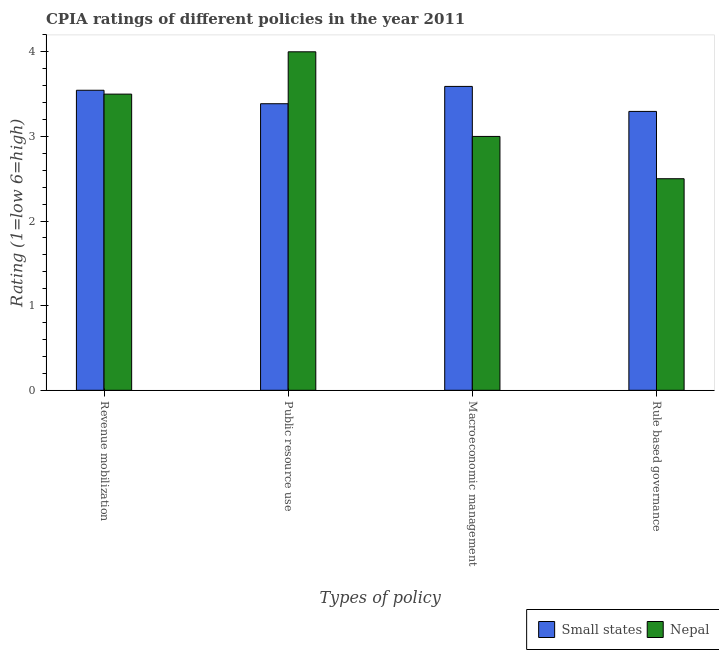How many different coloured bars are there?
Your answer should be compact. 2. How many bars are there on the 4th tick from the left?
Offer a very short reply. 2. How many bars are there on the 1st tick from the right?
Your response must be concise. 2. What is the label of the 1st group of bars from the left?
Ensure brevity in your answer.  Revenue mobilization. Across all countries, what is the maximum cpia rating of public resource use?
Ensure brevity in your answer.  4. Across all countries, what is the minimum cpia rating of public resource use?
Provide a succinct answer. 3.39. In which country was the cpia rating of rule based governance maximum?
Ensure brevity in your answer.  Small states. In which country was the cpia rating of macroeconomic management minimum?
Keep it short and to the point. Nepal. What is the total cpia rating of revenue mobilization in the graph?
Your answer should be very brief. 7.05. What is the difference between the cpia rating of rule based governance in Small states and that in Nepal?
Your answer should be compact. 0.8. What is the difference between the cpia rating of macroeconomic management in Nepal and the cpia rating of rule based governance in Small states?
Keep it short and to the point. -0.3. What is the average cpia rating of revenue mobilization per country?
Your answer should be compact. 3.52. What is the difference between the cpia rating of macroeconomic management and cpia rating of public resource use in Nepal?
Provide a short and direct response. -1. What is the ratio of the cpia rating of macroeconomic management in Small states to that in Nepal?
Make the answer very short. 1.2. Is the cpia rating of rule based governance in Small states less than that in Nepal?
Offer a terse response. No. Is the difference between the cpia rating of rule based governance in Small states and Nepal greater than the difference between the cpia rating of macroeconomic management in Small states and Nepal?
Provide a short and direct response. Yes. What is the difference between the highest and the second highest cpia rating of revenue mobilization?
Provide a short and direct response. 0.05. What is the difference between the highest and the lowest cpia rating of revenue mobilization?
Provide a succinct answer. 0.05. What does the 1st bar from the left in Macroeconomic management represents?
Your answer should be compact. Small states. What does the 1st bar from the right in Public resource use represents?
Your response must be concise. Nepal. Is it the case that in every country, the sum of the cpia rating of revenue mobilization and cpia rating of public resource use is greater than the cpia rating of macroeconomic management?
Offer a terse response. Yes. How many bars are there?
Provide a succinct answer. 8. Does the graph contain any zero values?
Offer a very short reply. No. Where does the legend appear in the graph?
Provide a succinct answer. Bottom right. What is the title of the graph?
Keep it short and to the point. CPIA ratings of different policies in the year 2011. Does "Macedonia" appear as one of the legend labels in the graph?
Make the answer very short. No. What is the label or title of the X-axis?
Ensure brevity in your answer.  Types of policy. What is the label or title of the Y-axis?
Keep it short and to the point. Rating (1=low 6=high). What is the Rating (1=low 6=high) in Small states in Revenue mobilization?
Ensure brevity in your answer.  3.55. What is the Rating (1=low 6=high) of Small states in Public resource use?
Offer a very short reply. 3.39. What is the Rating (1=low 6=high) of Nepal in Public resource use?
Your response must be concise. 4. What is the Rating (1=low 6=high) in Small states in Macroeconomic management?
Provide a succinct answer. 3.59. What is the Rating (1=low 6=high) of Small states in Rule based governance?
Ensure brevity in your answer.  3.3. What is the Rating (1=low 6=high) of Nepal in Rule based governance?
Provide a succinct answer. 2.5. Across all Types of policy, what is the maximum Rating (1=low 6=high) of Small states?
Give a very brief answer. 3.59. Across all Types of policy, what is the maximum Rating (1=low 6=high) of Nepal?
Provide a short and direct response. 4. Across all Types of policy, what is the minimum Rating (1=low 6=high) in Small states?
Provide a succinct answer. 3.3. What is the total Rating (1=low 6=high) in Small states in the graph?
Offer a very short reply. 13.82. What is the difference between the Rating (1=low 6=high) in Small states in Revenue mobilization and that in Public resource use?
Ensure brevity in your answer.  0.16. What is the difference between the Rating (1=low 6=high) of Small states in Revenue mobilization and that in Macroeconomic management?
Offer a terse response. -0.05. What is the difference between the Rating (1=low 6=high) in Small states in Revenue mobilization and that in Rule based governance?
Ensure brevity in your answer.  0.25. What is the difference between the Rating (1=low 6=high) of Nepal in Revenue mobilization and that in Rule based governance?
Ensure brevity in your answer.  1. What is the difference between the Rating (1=low 6=high) of Small states in Public resource use and that in Macroeconomic management?
Ensure brevity in your answer.  -0.2. What is the difference between the Rating (1=low 6=high) in Small states in Public resource use and that in Rule based governance?
Your answer should be very brief. 0.09. What is the difference between the Rating (1=low 6=high) of Small states in Macroeconomic management and that in Rule based governance?
Make the answer very short. 0.3. What is the difference between the Rating (1=low 6=high) in Small states in Revenue mobilization and the Rating (1=low 6=high) in Nepal in Public resource use?
Offer a terse response. -0.45. What is the difference between the Rating (1=low 6=high) of Small states in Revenue mobilization and the Rating (1=low 6=high) of Nepal in Macroeconomic management?
Provide a succinct answer. 0.55. What is the difference between the Rating (1=low 6=high) of Small states in Revenue mobilization and the Rating (1=low 6=high) of Nepal in Rule based governance?
Your answer should be very brief. 1.05. What is the difference between the Rating (1=low 6=high) in Small states in Public resource use and the Rating (1=low 6=high) in Nepal in Macroeconomic management?
Your answer should be very brief. 0.39. What is the difference between the Rating (1=low 6=high) in Small states in Public resource use and the Rating (1=low 6=high) in Nepal in Rule based governance?
Your answer should be very brief. 0.89. What is the average Rating (1=low 6=high) of Small states per Types of policy?
Keep it short and to the point. 3.45. What is the difference between the Rating (1=low 6=high) in Small states and Rating (1=low 6=high) in Nepal in Revenue mobilization?
Offer a terse response. 0.05. What is the difference between the Rating (1=low 6=high) in Small states and Rating (1=low 6=high) in Nepal in Public resource use?
Provide a succinct answer. -0.61. What is the difference between the Rating (1=low 6=high) in Small states and Rating (1=low 6=high) in Nepal in Macroeconomic management?
Your answer should be compact. 0.59. What is the difference between the Rating (1=low 6=high) of Small states and Rating (1=low 6=high) of Nepal in Rule based governance?
Offer a very short reply. 0.8. What is the ratio of the Rating (1=low 6=high) of Small states in Revenue mobilization to that in Public resource use?
Make the answer very short. 1.05. What is the ratio of the Rating (1=low 6=high) in Nepal in Revenue mobilization to that in Public resource use?
Your answer should be very brief. 0.88. What is the ratio of the Rating (1=low 6=high) in Small states in Revenue mobilization to that in Macroeconomic management?
Provide a short and direct response. 0.99. What is the ratio of the Rating (1=low 6=high) in Small states in Revenue mobilization to that in Rule based governance?
Ensure brevity in your answer.  1.08. What is the ratio of the Rating (1=low 6=high) in Small states in Public resource use to that in Macroeconomic management?
Keep it short and to the point. 0.94. What is the ratio of the Rating (1=low 6=high) in Nepal in Public resource use to that in Macroeconomic management?
Offer a terse response. 1.33. What is the ratio of the Rating (1=low 6=high) of Small states in Public resource use to that in Rule based governance?
Provide a succinct answer. 1.03. What is the ratio of the Rating (1=low 6=high) of Small states in Macroeconomic management to that in Rule based governance?
Offer a terse response. 1.09. What is the difference between the highest and the second highest Rating (1=low 6=high) in Small states?
Keep it short and to the point. 0.05. What is the difference between the highest and the second highest Rating (1=low 6=high) in Nepal?
Provide a succinct answer. 0.5. What is the difference between the highest and the lowest Rating (1=low 6=high) in Small states?
Provide a short and direct response. 0.3. 